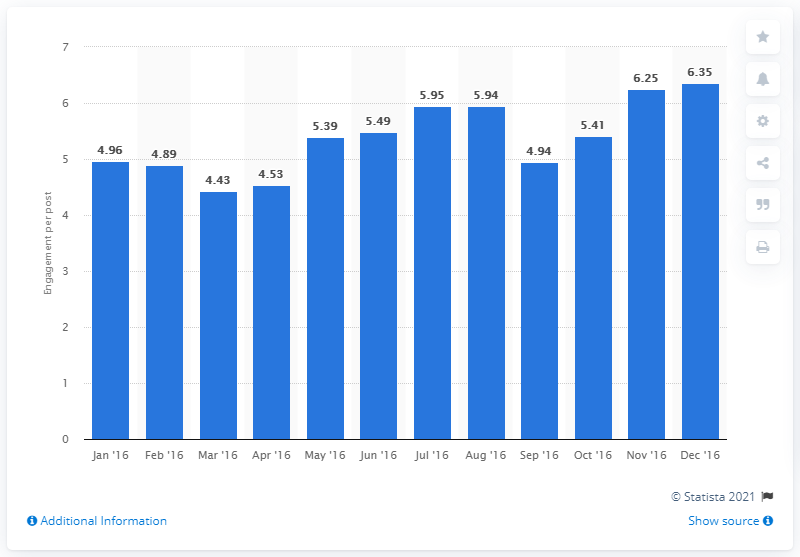Give some essential details in this illustration. The average number of interactions per brand post was 6.35. 